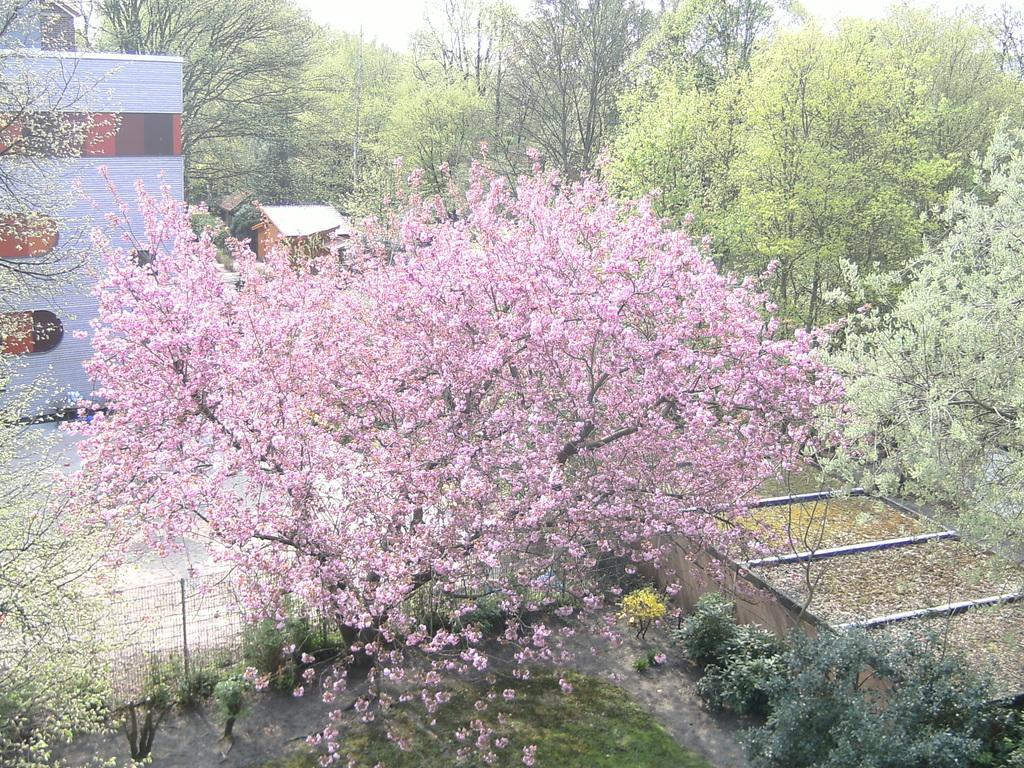What type of vegetation can be seen in the image? There are trees, plants, and grassy lands in the image. What structures are present in the image? There are buildings in the image. What type of barrier can be seen in the image? There is fencing in the image. How many giants can be seen interacting with the plants in the image? There are no giants present in the image; it features trees, plants, buildings, and fencing. What type of fruit is being held by the bat in the image? There is no bat or fruit present in the image. 